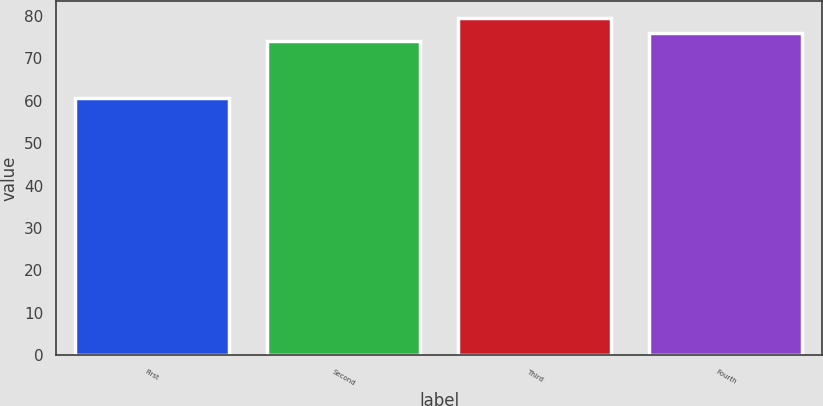Convert chart to OTSL. <chart><loc_0><loc_0><loc_500><loc_500><bar_chart><fcel>First<fcel>Second<fcel>Third<fcel>Fourth<nl><fcel>60.67<fcel>73.96<fcel>79.47<fcel>75.84<nl></chart> 